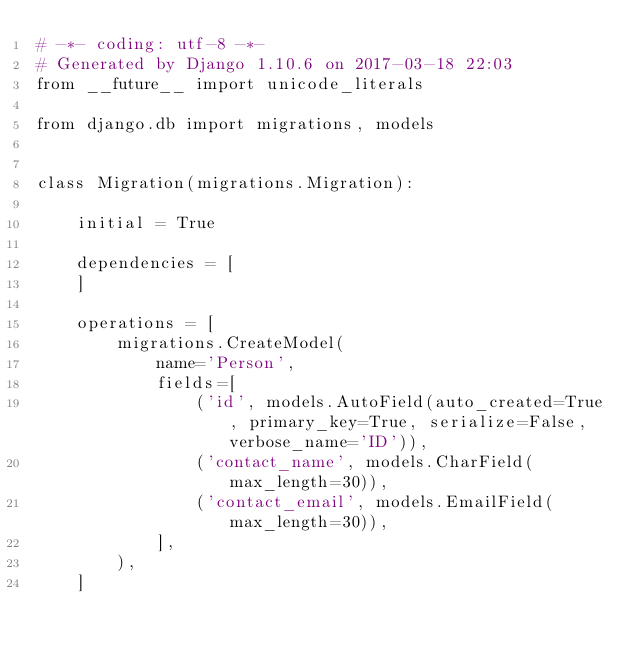Convert code to text. <code><loc_0><loc_0><loc_500><loc_500><_Python_># -*- coding: utf-8 -*-
# Generated by Django 1.10.6 on 2017-03-18 22:03
from __future__ import unicode_literals

from django.db import migrations, models


class Migration(migrations.Migration):

    initial = True

    dependencies = [
    ]

    operations = [
        migrations.CreateModel(
            name='Person',
            fields=[
                ('id', models.AutoField(auto_created=True, primary_key=True, serialize=False, verbose_name='ID')),
                ('contact_name', models.CharField(max_length=30)),
                ('contact_email', models.EmailField(max_length=30)),
            ],
        ),
    ]
</code> 